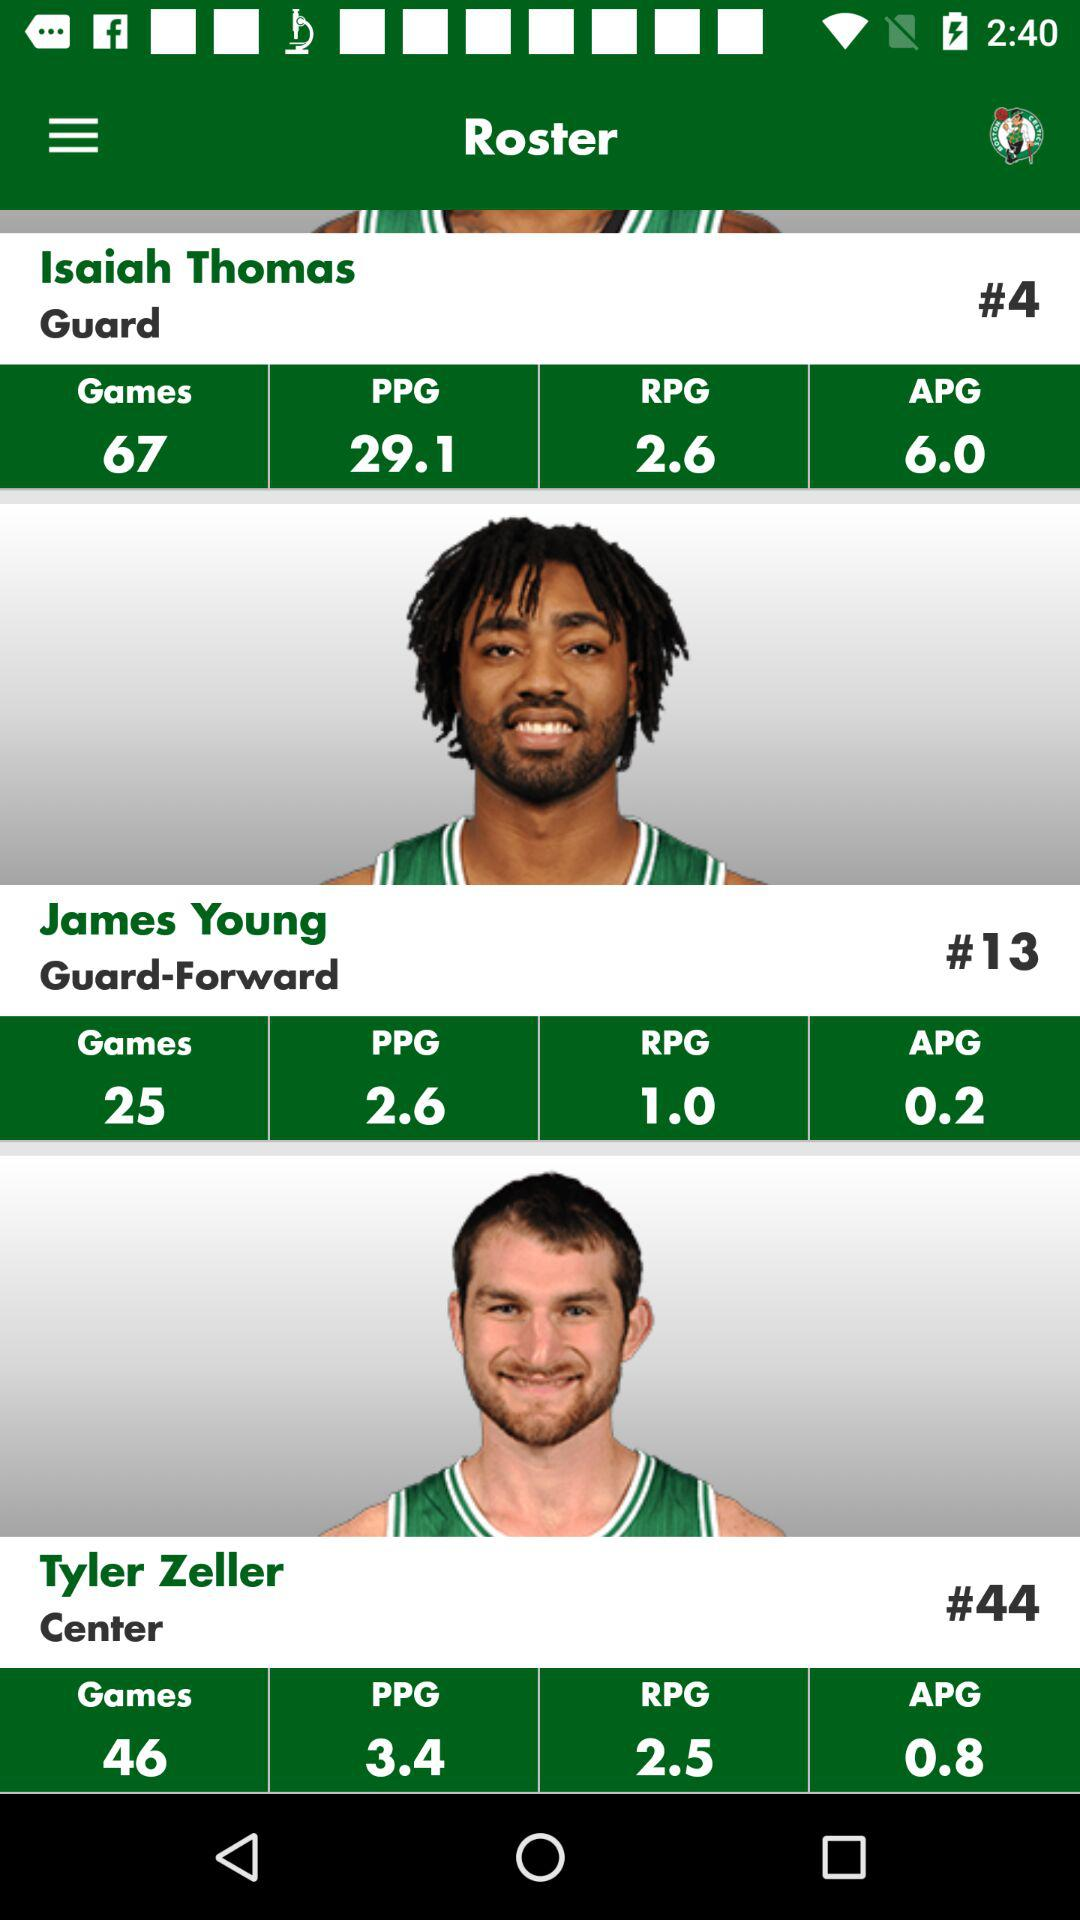What is the number of games played by Tyler Zeller? The number of games played by Tyler Zeller is 46. 